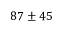Convert formula to latex. <formula><loc_0><loc_0><loc_500><loc_500>8 7 \pm 4 5</formula> 